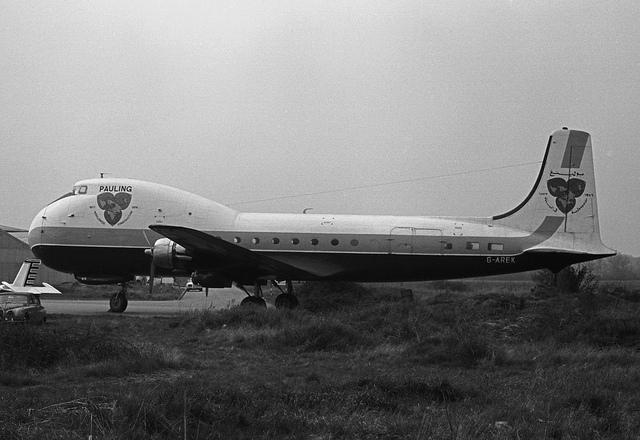How many engines on the plane?
Give a very brief answer. 2. How many airplanes are there?
Give a very brief answer. 2. 